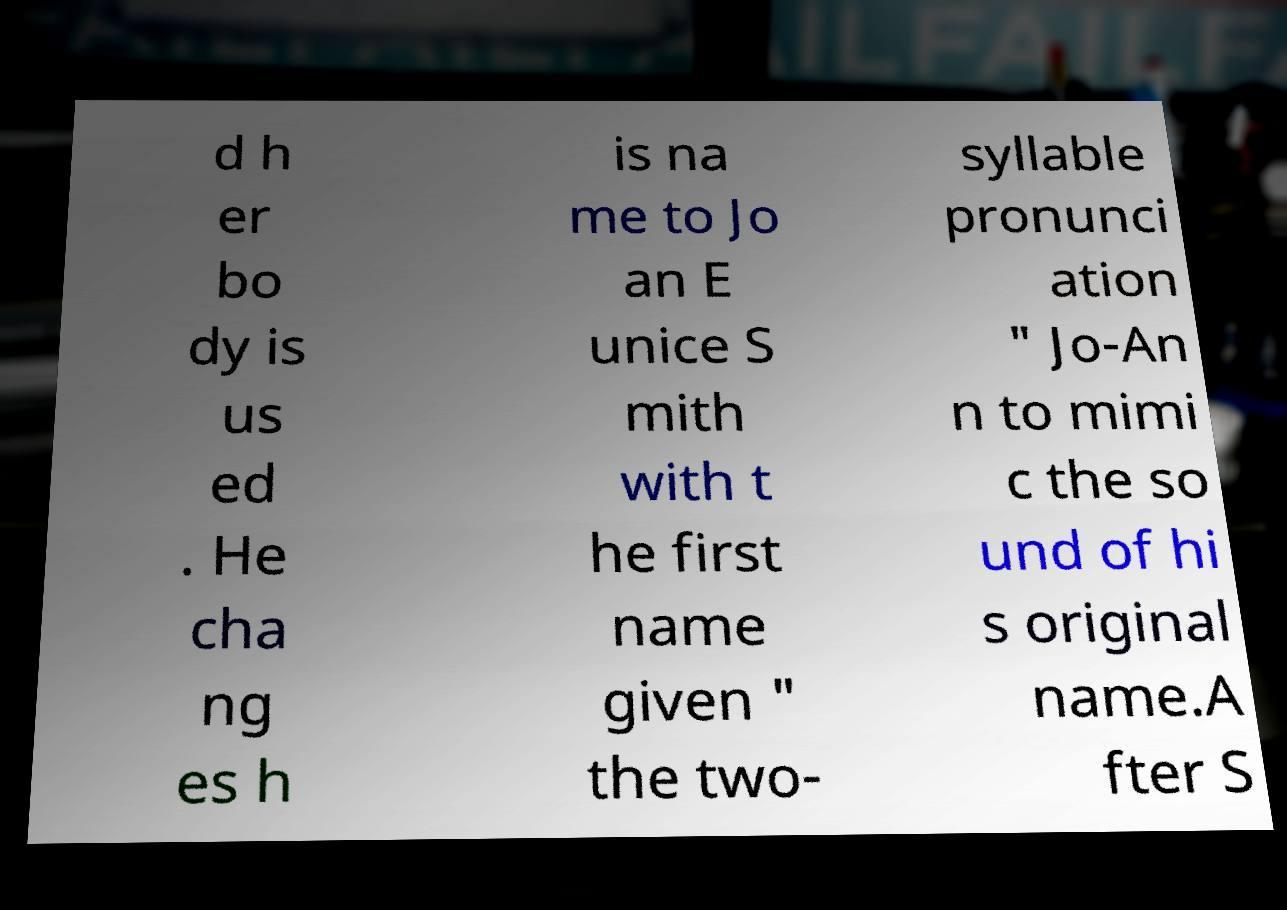Could you assist in decoding the text presented in this image and type it out clearly? d h er bo dy is us ed . He cha ng es h is na me to Jo an E unice S mith with t he first name given " the two- syllable pronunci ation " Jo-An n to mimi c the so und of hi s original name.A fter S 